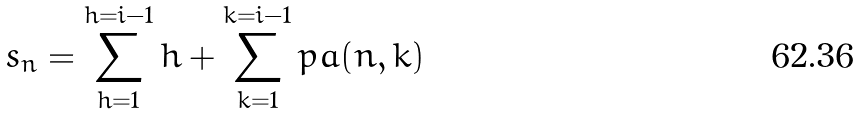<formula> <loc_0><loc_0><loc_500><loc_500>s _ { n } = \sum _ { h = 1 } ^ { h = i - 1 } h + \sum _ { k = 1 } ^ { k = i - 1 } p a ( n , k )</formula> 